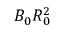<formula> <loc_0><loc_0><loc_500><loc_500>B _ { 0 } R _ { 0 } ^ { 2 }</formula> 